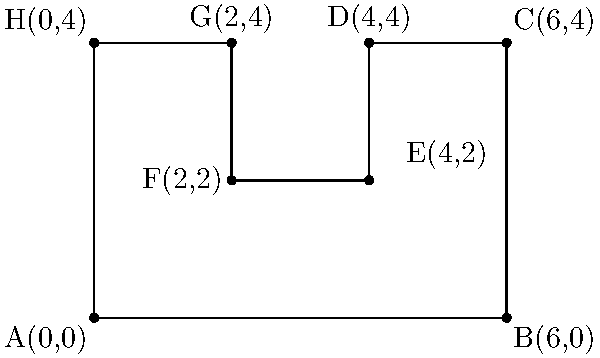The coffee shop where you work on weekends has an irregularly shaped seating area as shown in the coordinate system above. Each unit represents 1 meter. Calculate the total area of this seating arrangement using coordinate geometry methods. To find the area of this irregular shape, we can break it down into rectangles:

1. Rectangle ABCH:
   Area = 6 * 4 = 24 m²

2. Subtract the area of rectangle DEFG:
   Area to subtract = 2 * 2 = 4 m²

The total area is the difference between these two rectangles.

Step-by-step calculation:
1. Area of ABCH = length * width = 6 * 4 = 24 m²
2. Area of DEFG = length * width = 2 * 2 = 4 m²
3. Total Area = Area of ABCH - Area of DEFG
              = 24 m² - 4 m²
              = 20 m²

Therefore, the total area of the seating arrangement is 20 square meters.
Answer: 20 m² 